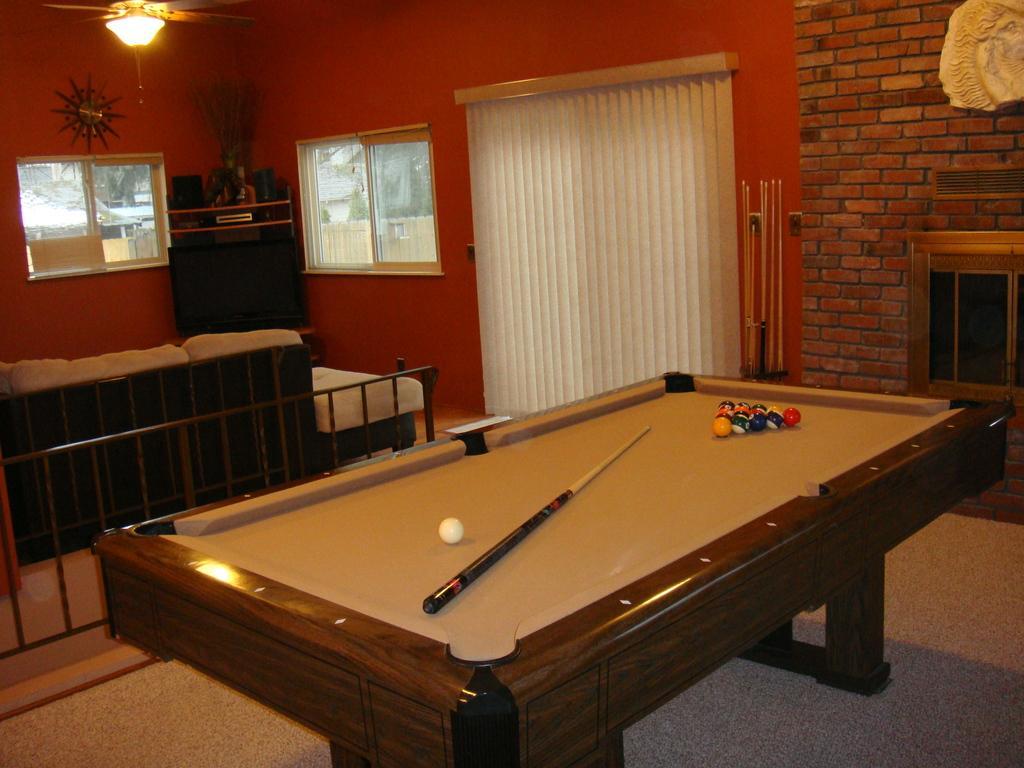In one or two sentences, can you explain what this image depicts? In this image there is a snooker table on which there are snooker balls and snooker stick. At the right side of the image there is a red color brick color wall and at the left side of the image there is a window and wardrobe and at the middle of the image there is a curtain 